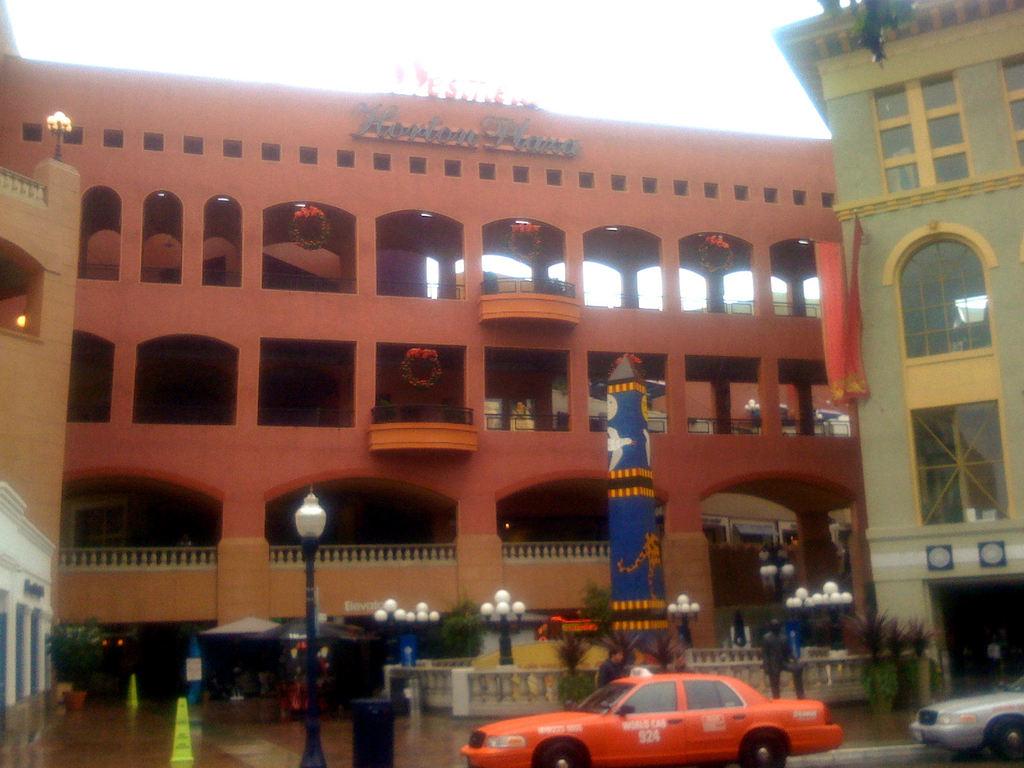What is the cab number of the orange cab?
Provide a short and direct response. 924. What is the name of the reddish building?
Your answer should be compact. Horton plaza. 